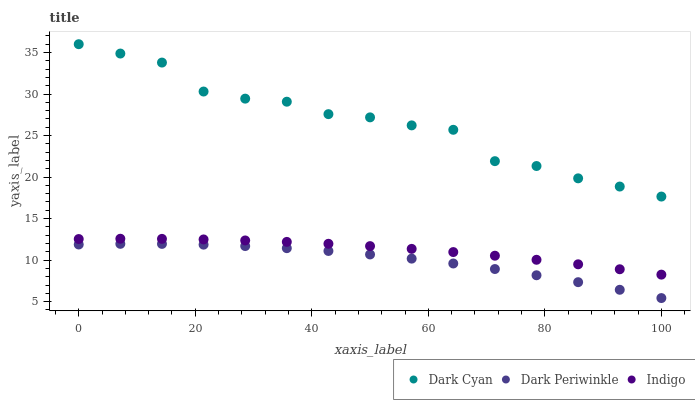Does Dark Periwinkle have the minimum area under the curve?
Answer yes or no. Yes. Does Dark Cyan have the maximum area under the curve?
Answer yes or no. Yes. Does Indigo have the minimum area under the curve?
Answer yes or no. No. Does Indigo have the maximum area under the curve?
Answer yes or no. No. Is Indigo the smoothest?
Answer yes or no. Yes. Is Dark Cyan the roughest?
Answer yes or no. Yes. Is Dark Periwinkle the smoothest?
Answer yes or no. No. Is Dark Periwinkle the roughest?
Answer yes or no. No. Does Dark Periwinkle have the lowest value?
Answer yes or no. Yes. Does Indigo have the lowest value?
Answer yes or no. No. Does Dark Cyan have the highest value?
Answer yes or no. Yes. Does Indigo have the highest value?
Answer yes or no. No. Is Indigo less than Dark Cyan?
Answer yes or no. Yes. Is Indigo greater than Dark Periwinkle?
Answer yes or no. Yes. Does Indigo intersect Dark Cyan?
Answer yes or no. No. 